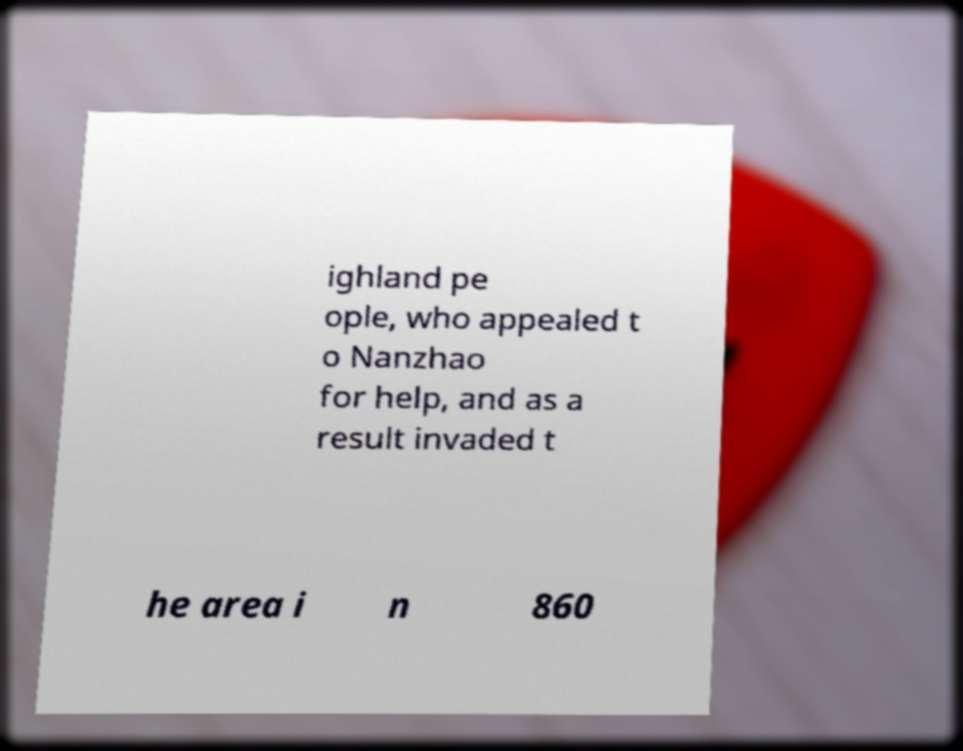There's text embedded in this image that I need extracted. Can you transcribe it verbatim? ighland pe ople, who appealed t o Nanzhao for help, and as a result invaded t he area i n 860 